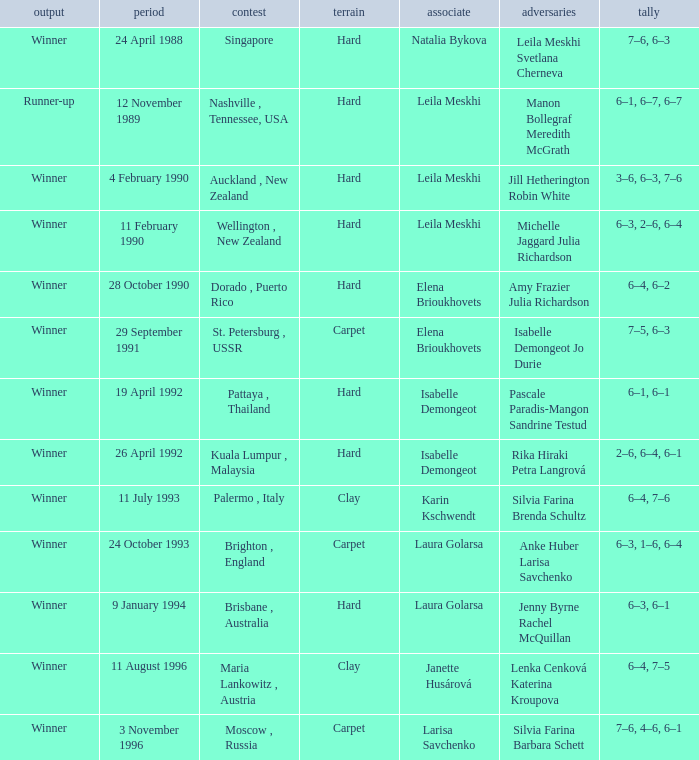In what Tournament was the Score of 3–6, 6–3, 7–6 in a match played on a hard Surface? Auckland , New Zealand. 